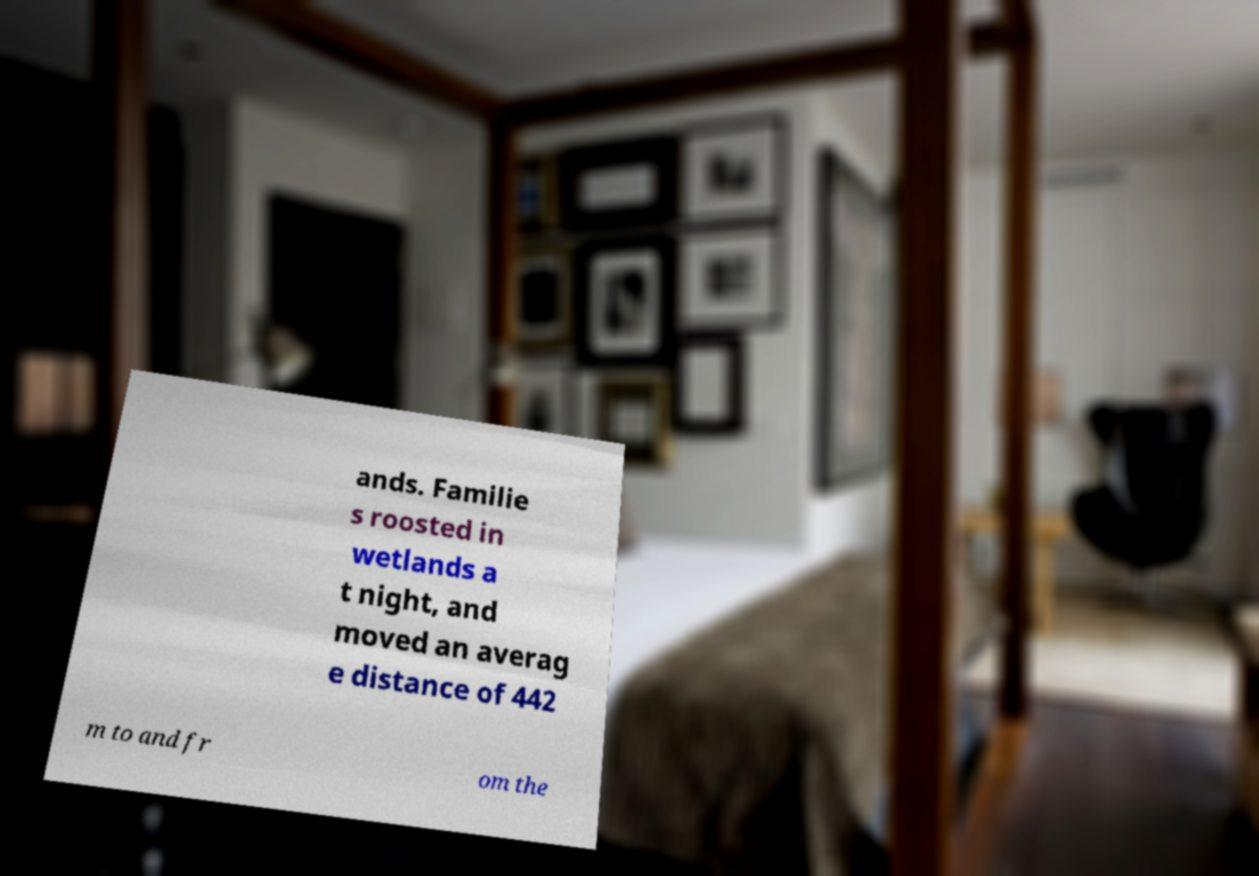Please identify and transcribe the text found in this image. ands. Familie s roosted in wetlands a t night, and moved an averag e distance of 442 m to and fr om the 